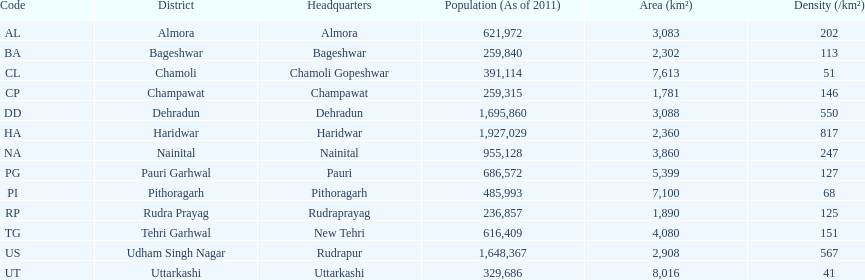Which central office is located in a district with the same name and has a density of 202? Almora. 